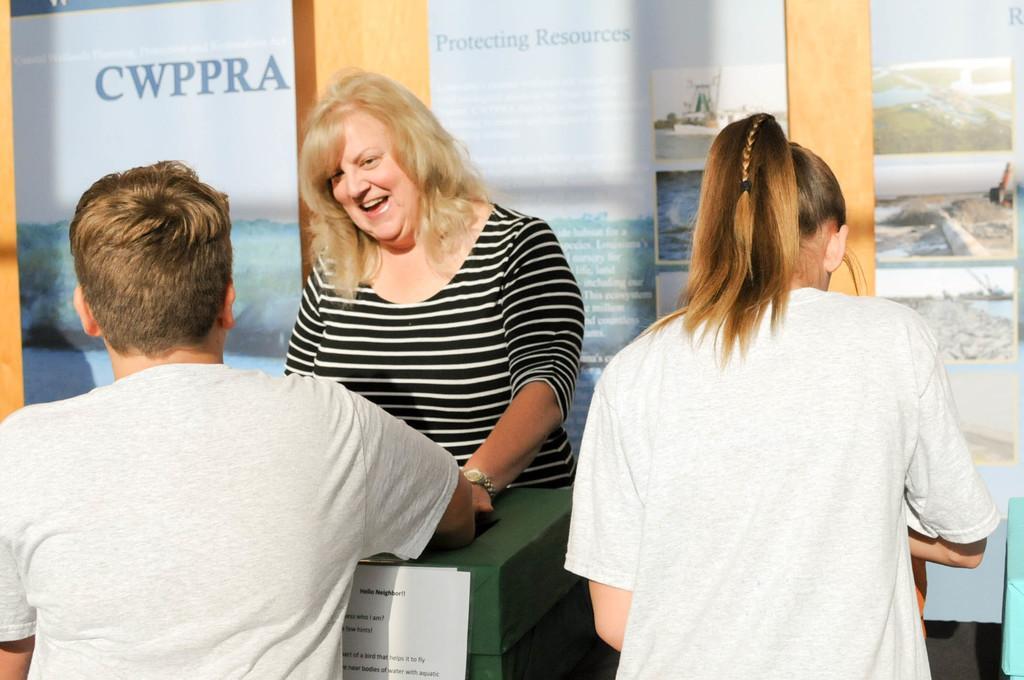Can you describe this image briefly? In this picture we can see three people where a woman wore a watch and smiling, paper and some objects and in the background we can see posters on the wall. 